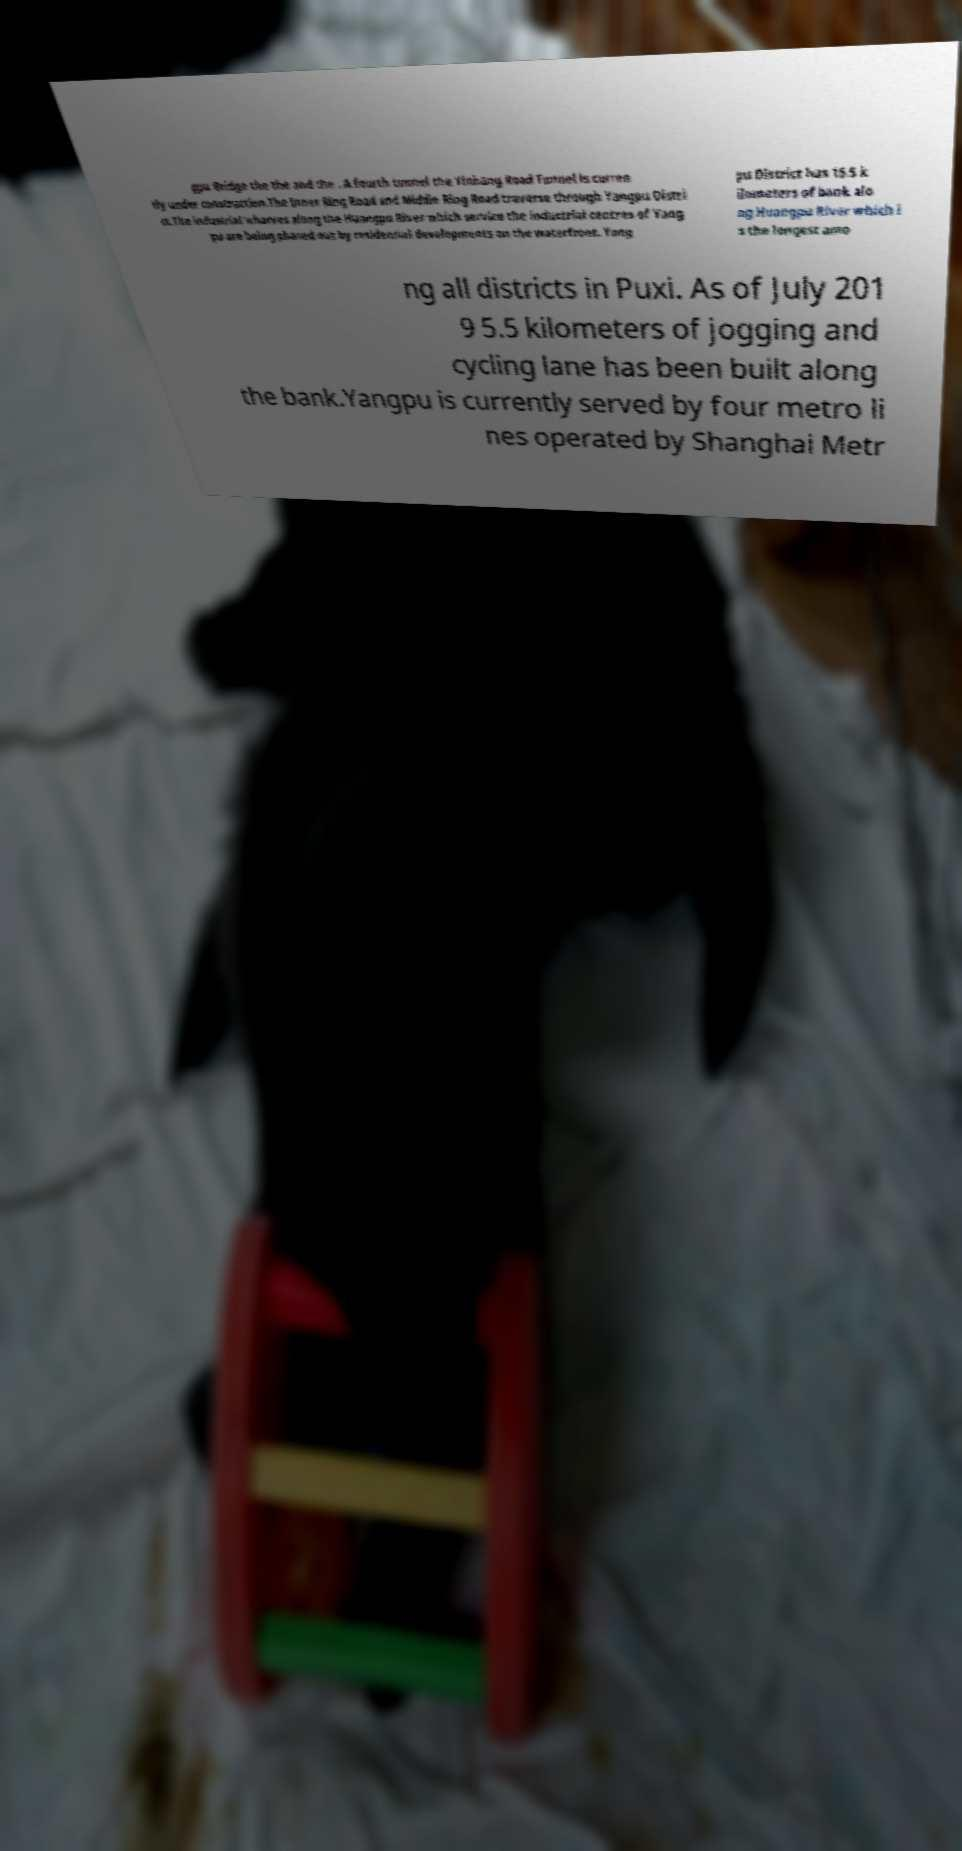Could you extract and type out the text from this image? gpu Bridge the the and the . A fourth tunnel the Yinhang Road Tunnel is curren tly under construction.The Inner Ring Road and Middle Ring Road traverse through Yangpu Distri ct.The industrial wharves along the Huangpu River which service the industrial centres of Yang pu are being phased out by residential developments on the waterfront. Yang pu District has 15.5 k ilometers of bank alo ng Huangpu River which i s the longest amo ng all districts in Puxi. As of July 201 9 5.5 kilometers of jogging and cycling lane has been built along the bank.Yangpu is currently served by four metro li nes operated by Shanghai Metr 